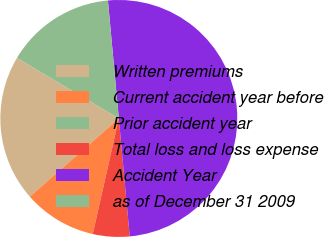Convert chart to OTSL. <chart><loc_0><loc_0><loc_500><loc_500><pie_chart><fcel>Written premiums<fcel>Current accident year before<fcel>Prior accident year<fcel>Total loss and loss expense<fcel>Accident Year<fcel>as of December 31 2009<nl><fcel>20.0%<fcel>10.0%<fcel>0.0%<fcel>5.0%<fcel>49.99%<fcel>15.0%<nl></chart> 